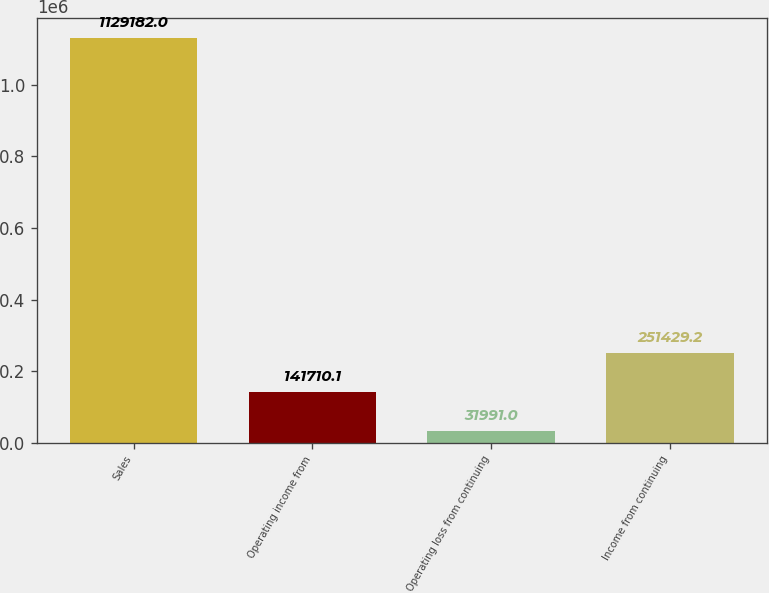Convert chart to OTSL. <chart><loc_0><loc_0><loc_500><loc_500><bar_chart><fcel>Sales<fcel>Operating income from<fcel>Operating loss from continuing<fcel>Income from continuing<nl><fcel>1.12918e+06<fcel>141710<fcel>31991<fcel>251429<nl></chart> 